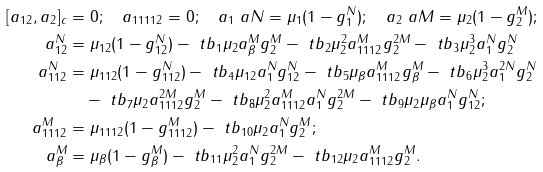Convert formula to latex. <formula><loc_0><loc_0><loc_500><loc_500>[ a _ { 1 2 } , a _ { 2 } ] _ { c } & = 0 ; \quad a _ { 1 1 1 1 2 } = 0 ; \quad a _ { 1 } \ a { N } = \mu _ { 1 } ( 1 - g _ { 1 } ^ { N } ) ; \quad a _ { 2 } \ a { M } = \mu _ { 2 } ( 1 - g _ { 2 } ^ { M } ) ; \\ a _ { 1 2 } ^ { N } & = \mu _ { 1 2 } ( 1 - g _ { 1 2 } ^ { N } ) - \ t b _ { 1 } \mu _ { 2 } a _ { \beta } ^ { M } g _ { 2 } ^ { M } - \ t b _ { 2 } \mu _ { 2 } ^ { 2 } a _ { 1 1 1 2 } ^ { M } g _ { 2 } ^ { 2 M } - \ t b _ { 3 } \mu _ { 2 } ^ { 3 } a _ { 1 } ^ { N } g _ { 2 } ^ { N } \\ a _ { 1 1 2 } ^ { N } & = \mu _ { 1 1 2 } ( 1 - g _ { 1 1 2 } ^ { N } ) - \ t b _ { 4 } \mu _ { 1 2 } a _ { 1 } ^ { N } g _ { 1 2 } ^ { N } - \ t b _ { 5 } \mu _ { \beta } a _ { 1 1 1 2 } ^ { M } g _ { \beta } ^ { M } - \ t b _ { 6 } \mu _ { 2 } ^ { 3 } a _ { 1 } ^ { 2 N } g _ { 2 } ^ { N } \\ & \quad - \ t b _ { 7 } \mu _ { 2 } a _ { 1 1 1 2 } ^ { 2 M } g _ { 2 } ^ { M } - \ t b _ { 8 } \mu _ { 2 } ^ { 2 } a _ { 1 1 1 2 } ^ { M } a _ { 1 } ^ { N } g _ { 2 } ^ { 2 M } - \ t b _ { 9 } \mu _ { 2 } \mu _ { \beta } a _ { 1 } ^ { N } g _ { 1 2 } ^ { N } ; \\ a _ { 1 1 1 2 } ^ { M } & = \mu _ { 1 1 1 2 } ( 1 - g _ { 1 1 1 2 } ^ { M } ) - \ t b _ { 1 0 } \mu _ { 2 } a _ { 1 } ^ { N } g _ { 2 } ^ { M } ; \\ a _ { \beta } ^ { M } & = \mu _ { \beta } ( 1 - g _ { \beta } ^ { M } ) - \ t b _ { 1 1 } \mu _ { 2 } ^ { 2 } a _ { 1 } ^ { N } g _ { 2 } ^ { 2 M } - \ t b _ { 1 2 } \mu _ { 2 } a _ { 1 1 1 2 } ^ { M } g _ { 2 } ^ { M } .</formula> 